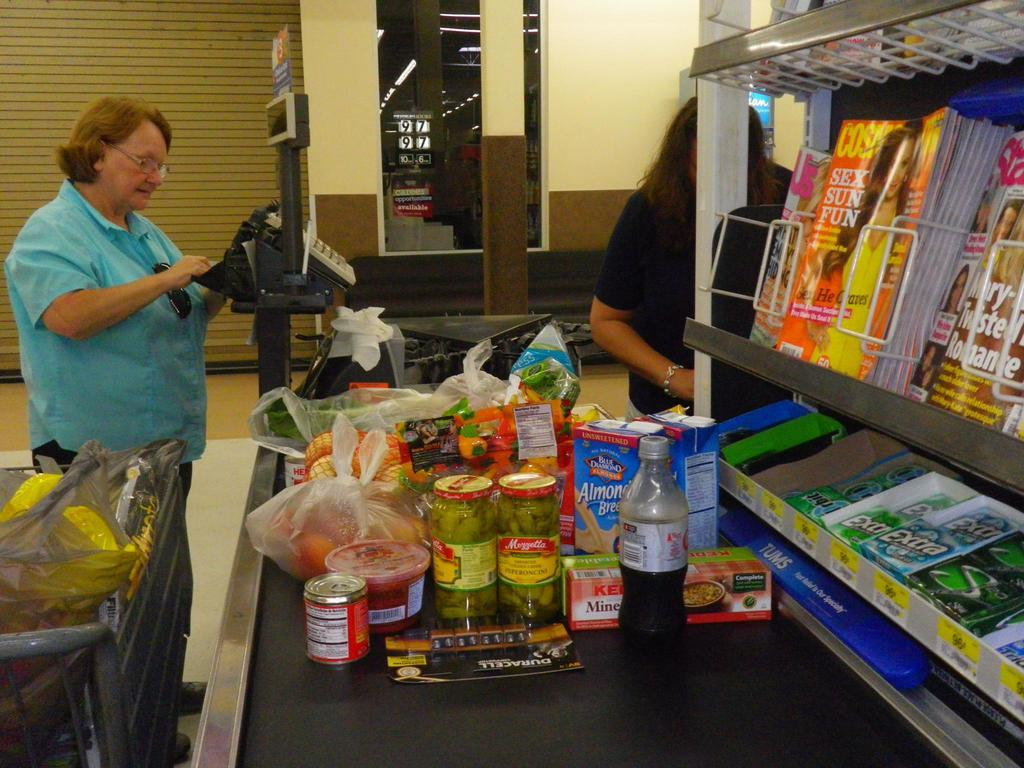<image>
Present a compact description of the photo's key features. grocery checkout line with row of cosmopolitan magazine 